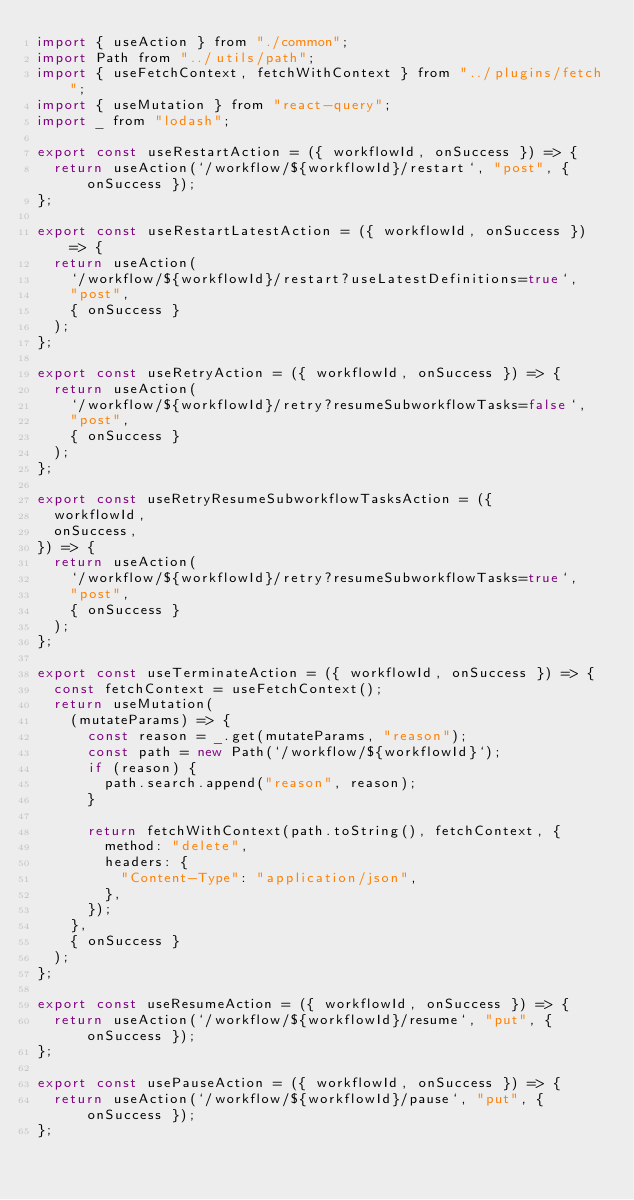Convert code to text. <code><loc_0><loc_0><loc_500><loc_500><_JavaScript_>import { useAction } from "./common";
import Path from "../utils/path";
import { useFetchContext, fetchWithContext } from "../plugins/fetch";
import { useMutation } from "react-query";
import _ from "lodash";

export const useRestartAction = ({ workflowId, onSuccess }) => {
  return useAction(`/workflow/${workflowId}/restart`, "post", { onSuccess });
};

export const useRestartLatestAction = ({ workflowId, onSuccess }) => {
  return useAction(
    `/workflow/${workflowId}/restart?useLatestDefinitions=true`,
    "post",
    { onSuccess }
  );
};

export const useRetryAction = ({ workflowId, onSuccess }) => {
  return useAction(
    `/workflow/${workflowId}/retry?resumeSubworkflowTasks=false`,
    "post",
    { onSuccess }
  );
};

export const useRetryResumeSubworkflowTasksAction = ({
  workflowId,
  onSuccess,
}) => {
  return useAction(
    `/workflow/${workflowId}/retry?resumeSubworkflowTasks=true`,
    "post",
    { onSuccess }
  );
};

export const useTerminateAction = ({ workflowId, onSuccess }) => {
  const fetchContext = useFetchContext();
  return useMutation(
    (mutateParams) => {
      const reason = _.get(mutateParams, "reason");
      const path = new Path(`/workflow/${workflowId}`);
      if (reason) {
        path.search.append("reason", reason);
      }

      return fetchWithContext(path.toString(), fetchContext, {
        method: "delete",
        headers: {
          "Content-Type": "application/json",
        },
      });
    },
    { onSuccess }
  );
};

export const useResumeAction = ({ workflowId, onSuccess }) => {
  return useAction(`/workflow/${workflowId}/resume`, "put", { onSuccess });
};

export const usePauseAction = ({ workflowId, onSuccess }) => {
  return useAction(`/workflow/${workflowId}/pause`, "put", { onSuccess });
};
</code> 